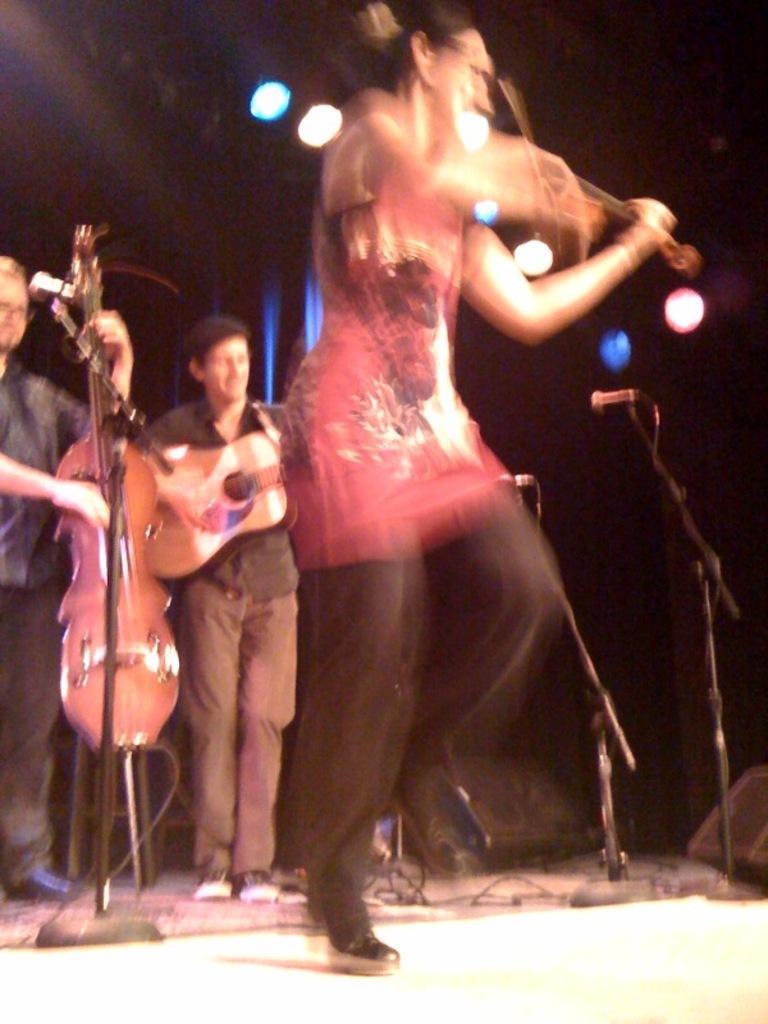How would you summarize this image in a sentence or two? This looks like a concert musical program. Here a person is playing violin the person who is playing violin is wearing pink dress with black bottom and they are also wearing shoes. And there is a mic with a mic stand here. There are so many wires. And here a person he is playing guitar here. And he is wearing black shirt there are also lights over here. And here it looks like a speaker. 